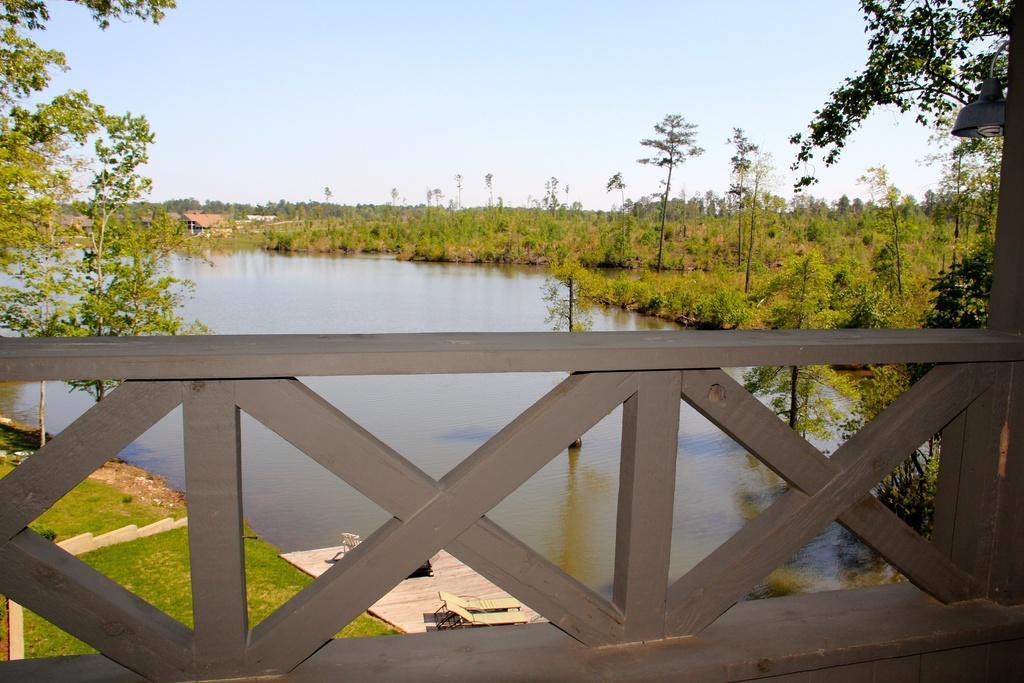Can you describe this image briefly? The picture is taken from the corridor of a house. In the foreground there is railing. In the center of the picture there are trees, plants, grass, soil, beach chairs and water. In the background there are houses and trees. Sky is clear and it is sunny. 